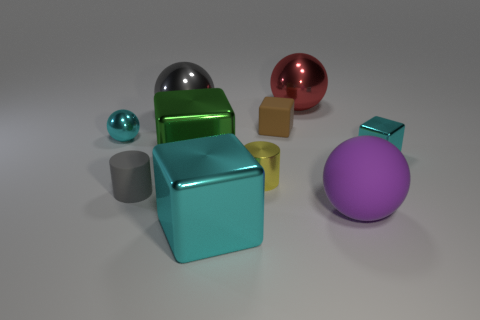What number of other objects are the same material as the red sphere?
Provide a short and direct response. 6. There is a tiny brown object; what shape is it?
Your response must be concise. Cube. How many large blue things have the same shape as the purple object?
Make the answer very short. 0. Is the number of cyan metallic spheres that are to the right of the large matte ball less than the number of tiny spheres that are on the left side of the shiny cylinder?
Provide a succinct answer. Yes. There is a metallic block that is to the left of the big cyan thing; what number of large matte balls are left of it?
Make the answer very short. 0. Are there any small yellow objects?
Keep it short and to the point. Yes. Is there a green block that has the same material as the large cyan thing?
Your answer should be compact. Yes. Is the number of shiny spheres that are to the right of the yellow cylinder greater than the number of matte balls right of the large red shiny ball?
Provide a succinct answer. No. Is the size of the green metal cube the same as the cyan ball?
Offer a very short reply. No. What color is the tiny rubber thing in front of the metallic cube on the right side of the large purple sphere?
Make the answer very short. Gray. 